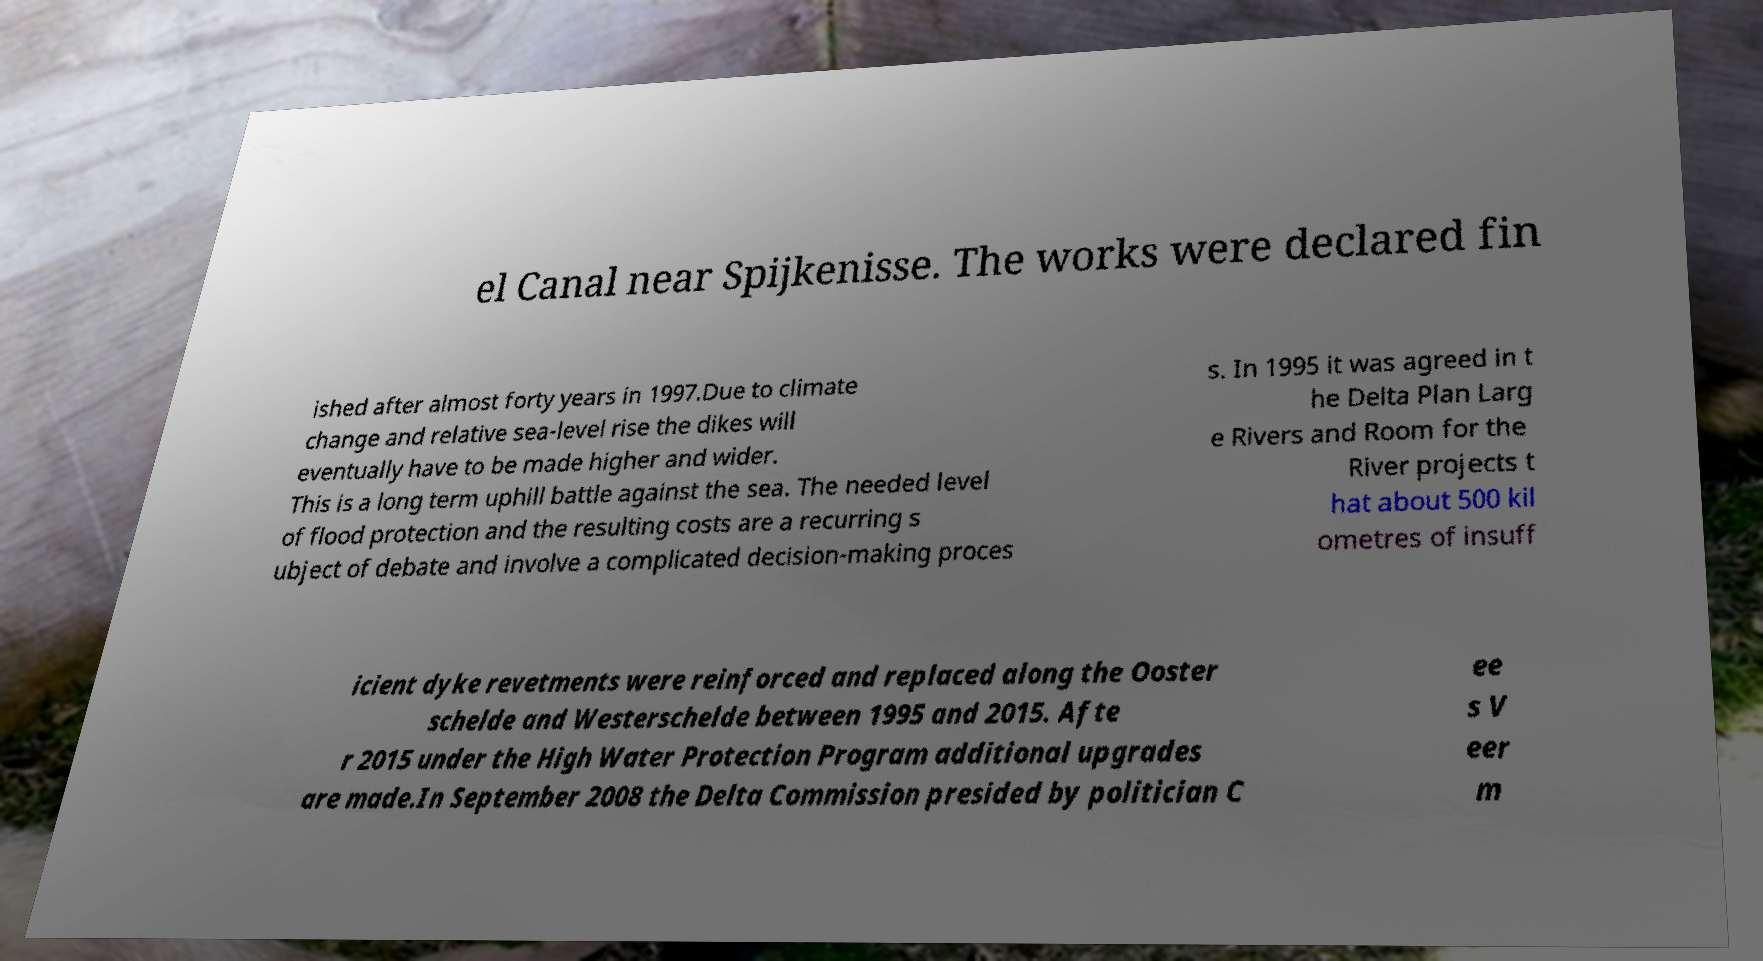Can you read and provide the text displayed in the image?This photo seems to have some interesting text. Can you extract and type it out for me? el Canal near Spijkenisse. The works were declared fin ished after almost forty years in 1997.Due to climate change and relative sea-level rise the dikes will eventually have to be made higher and wider. This is a long term uphill battle against the sea. The needed level of flood protection and the resulting costs are a recurring s ubject of debate and involve a complicated decision-making proces s. In 1995 it was agreed in t he Delta Plan Larg e Rivers and Room for the River projects t hat about 500 kil ometres of insuff icient dyke revetments were reinforced and replaced along the Ooster schelde and Westerschelde between 1995 and 2015. Afte r 2015 under the High Water Protection Program additional upgrades are made.In September 2008 the Delta Commission presided by politician C ee s V eer m 